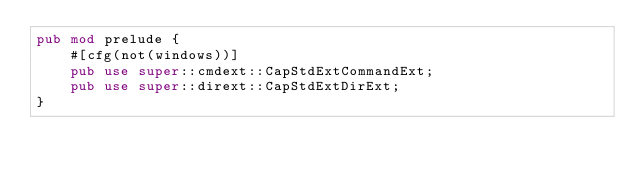Convert code to text. <code><loc_0><loc_0><loc_500><loc_500><_Rust_>pub mod prelude {
    #[cfg(not(windows))]
    pub use super::cmdext::CapStdExtCommandExt;
    pub use super::dirext::CapStdExtDirExt;
}
</code> 